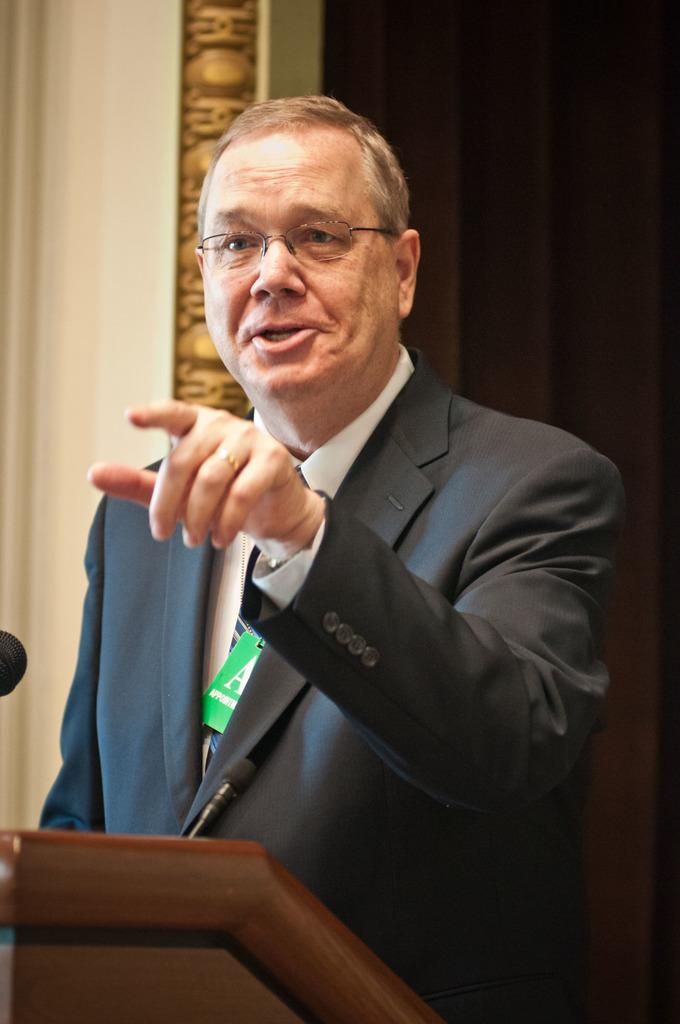Who is the main subject in the picture? There is an old man in the picture. What is the old man wearing? The old man is wearing a black suit. Where is the old man positioned in the image? The old man is standing in the front. What is the old man doing with his finger? The old man is showing his finger. What is the old man's emotional state in the image? The old man is shouting. What can be seen in the background of the picture? There is a wall in the background of the picture. Is there any window treatment associated with the wall? Yes, there is a curtain associated with the wall. What type of branch can be seen in the old man's hand in the image? There is no branch present in the image; the old man is showing his finger. What color is the paint on the wall in the background? There is no mention of paint or a specific color on the wall in the image; it is simply a wall with a curtain. 